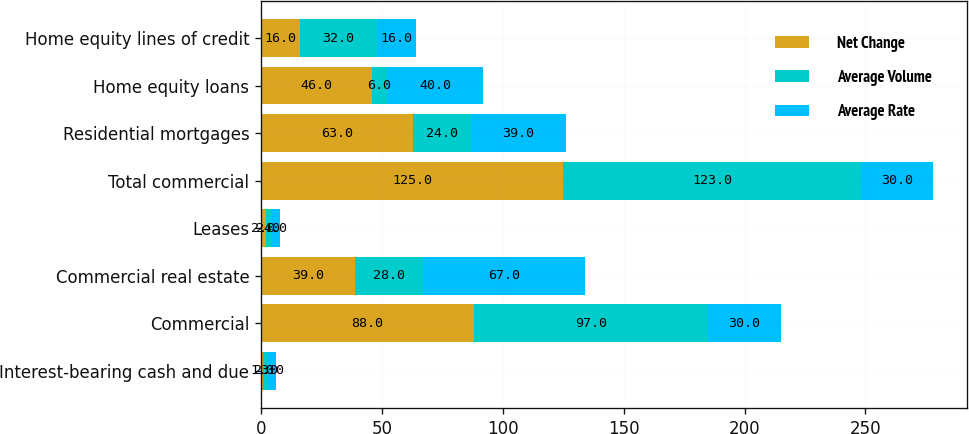<chart> <loc_0><loc_0><loc_500><loc_500><stacked_bar_chart><ecel><fcel>Interest-bearing cash and due<fcel>Commercial<fcel>Commercial real estate<fcel>Leases<fcel>Total commercial<fcel>Residential mortgages<fcel>Home equity loans<fcel>Home equity lines of credit<nl><fcel>Net Change<fcel>1<fcel>88<fcel>39<fcel>2<fcel>125<fcel>63<fcel>46<fcel>16<nl><fcel>Average Volume<fcel>2<fcel>97<fcel>28<fcel>2<fcel>123<fcel>24<fcel>6<fcel>32<nl><fcel>Average Rate<fcel>3<fcel>30<fcel>67<fcel>4<fcel>30<fcel>39<fcel>40<fcel>16<nl></chart> 